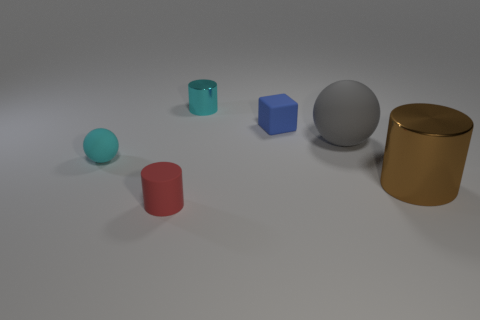Subtract all tiny cylinders. How many cylinders are left? 1 Add 2 small red matte cylinders. How many objects exist? 8 Subtract all blocks. How many objects are left? 5 Subtract all blue cylinders. Subtract all blue blocks. How many cylinders are left? 3 Subtract all large things. Subtract all purple matte blocks. How many objects are left? 4 Add 5 metal cylinders. How many metal cylinders are left? 7 Add 3 blue rubber blocks. How many blue rubber blocks exist? 4 Subtract 0 red spheres. How many objects are left? 6 